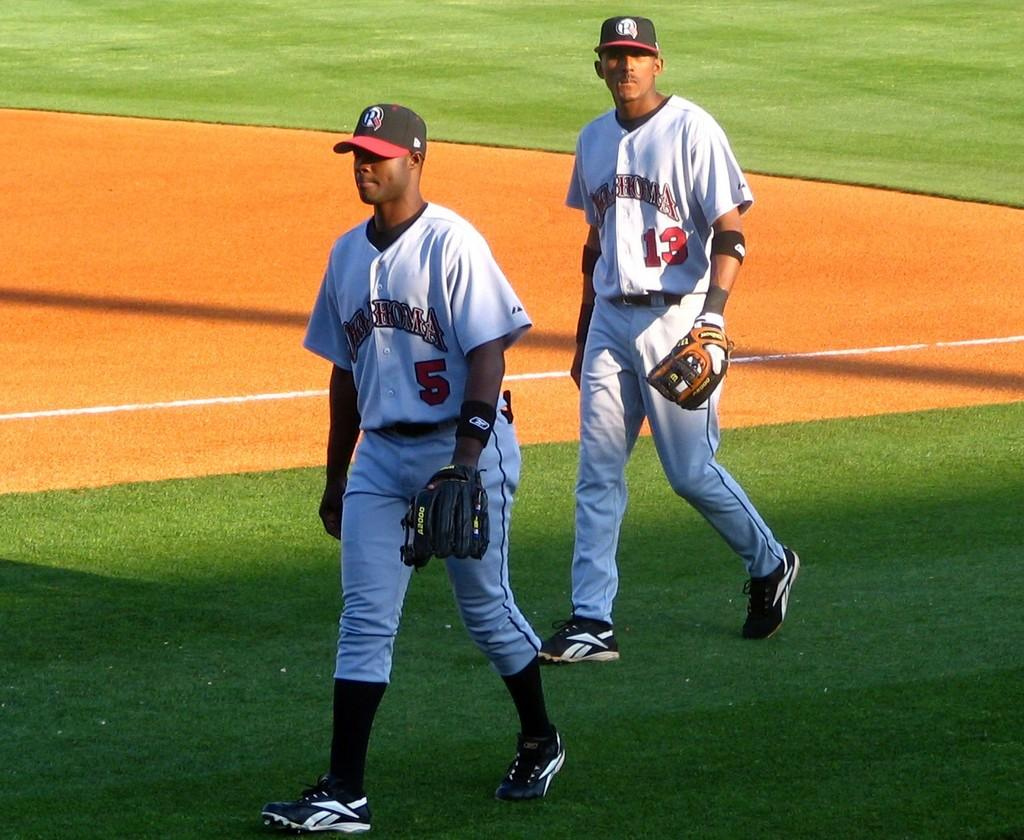<image>
Provide a brief description of the given image. Baseball player wearing number 5 walking with anothe wearing number 13. 